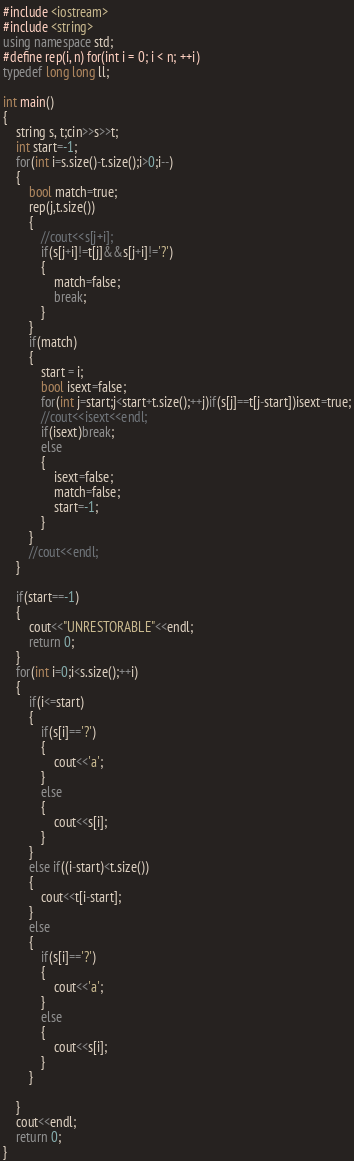Convert code to text. <code><loc_0><loc_0><loc_500><loc_500><_C++_>#include <iostream>
#include <string>
using namespace std;
#define rep(i, n) for(int i = 0; i < n; ++i)
typedef long long ll;

int main()
{
	string s, t;cin>>s>>t;
	int start=-1;
	for(int i=s.size()-t.size();i>0;i--)
	{
		bool match=true;
		rep(j,t.size())
		{
			//cout<<s[j+i];
			if(s[j+i]!=t[j]&&s[j+i]!='?')
			{
				match=false;
				break;
			}
		}
		if(match)
		{
			start = i;
			bool isext=false;
			for(int j=start;j<start+t.size();++j)if(s[j]==t[j-start])isext=true;
			//cout<<isext<<endl;
			if(isext)break;
			else 
			{
				isext=false;
				match=false;
				start=-1;
			}
		}
		//cout<<endl;
	}

	if(start==-1)
	{
		cout<<"UNRESTORABLE"<<endl;
		return 0;
	}
	for(int i=0;i<s.size();++i)
	{
		if(i<=start)
		{
			if(s[i]=='?')
			{
				cout<<'a';
			}
			else
			{
				cout<<s[i];
			}
		}
		else if((i-start)<t.size())
		{
			cout<<t[i-start];
		}
		else
		{
			if(s[i]=='?')
			{
				cout<<'a';
			}
			else
			{
				cout<<s[i];
			}
		}
		
	}
	cout<<endl;
	return 0;
}</code> 